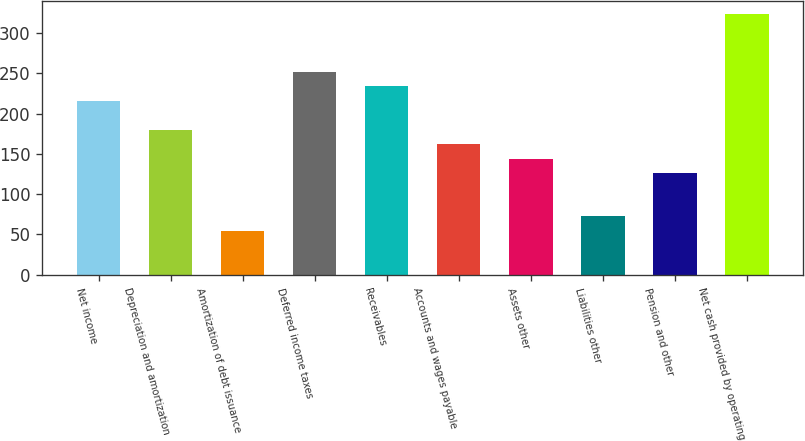<chart> <loc_0><loc_0><loc_500><loc_500><bar_chart><fcel>Net income<fcel>Depreciation and amortization<fcel>Amortization of debt issuance<fcel>Deferred income taxes<fcel>Receivables<fcel>Accounts and wages payable<fcel>Assets other<fcel>Liabilities other<fcel>Pension and other<fcel>Net cash provided by operating<nl><fcel>215.8<fcel>180<fcel>54.7<fcel>251.6<fcel>233.7<fcel>162.1<fcel>144.2<fcel>72.6<fcel>126.3<fcel>323.2<nl></chart> 